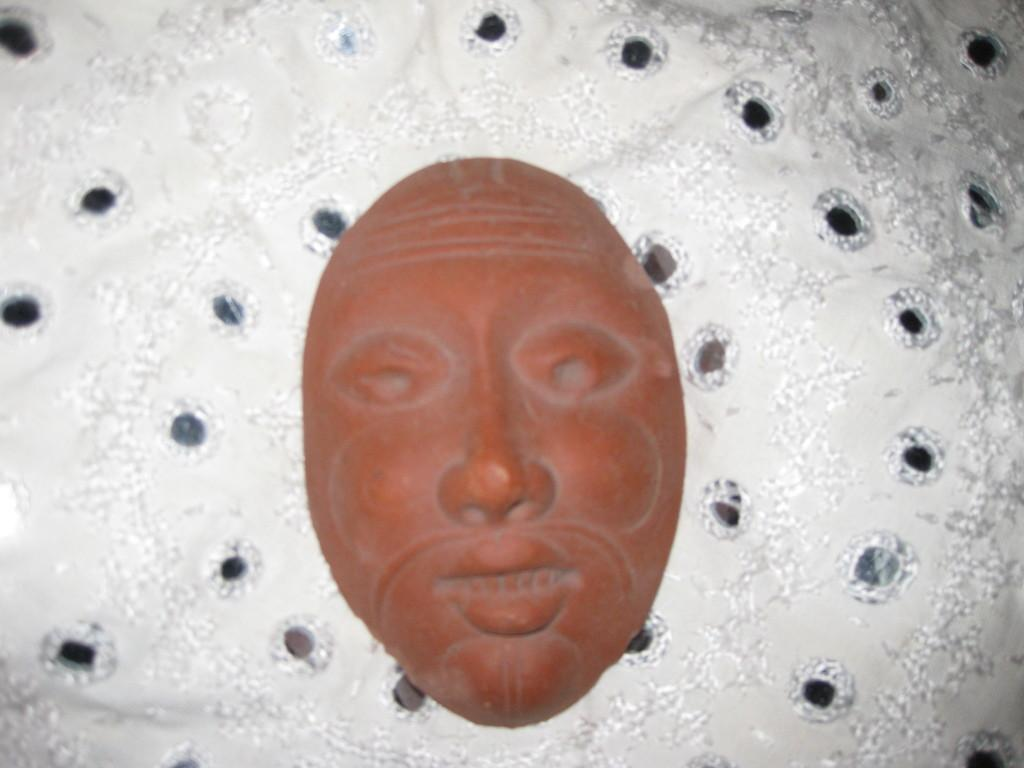What is the main subject in the center of the image? There is a mask in the center of the image. Can you describe anything else visible in the image? There is a cloth-like object in the background of the image. What type of fowl can be seen interacting with the mask in the image? There is no fowl present in the image, and the mask is not interacting with any other objects or creatures. 